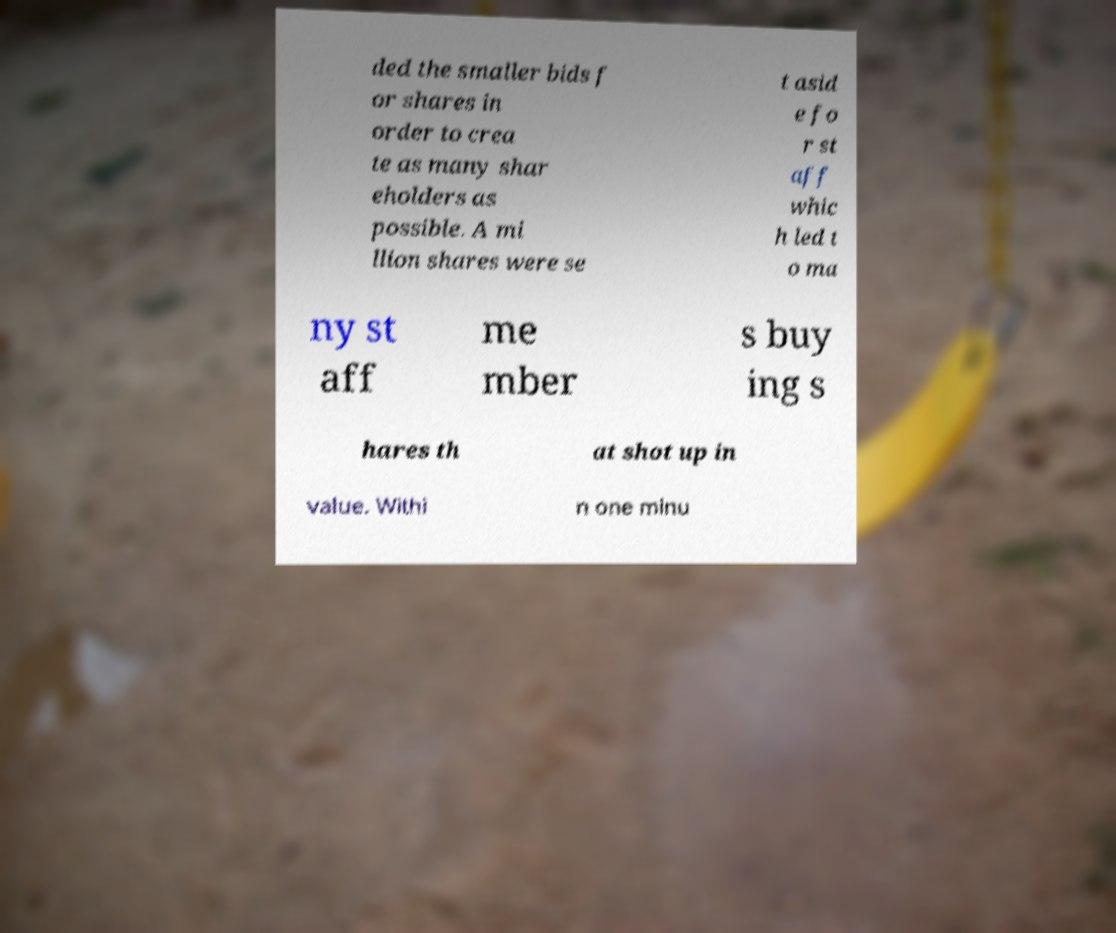Could you extract and type out the text from this image? ded the smaller bids f or shares in order to crea te as many shar eholders as possible. A mi llion shares were se t asid e fo r st aff whic h led t o ma ny st aff me mber s buy ing s hares th at shot up in value. Withi n one minu 